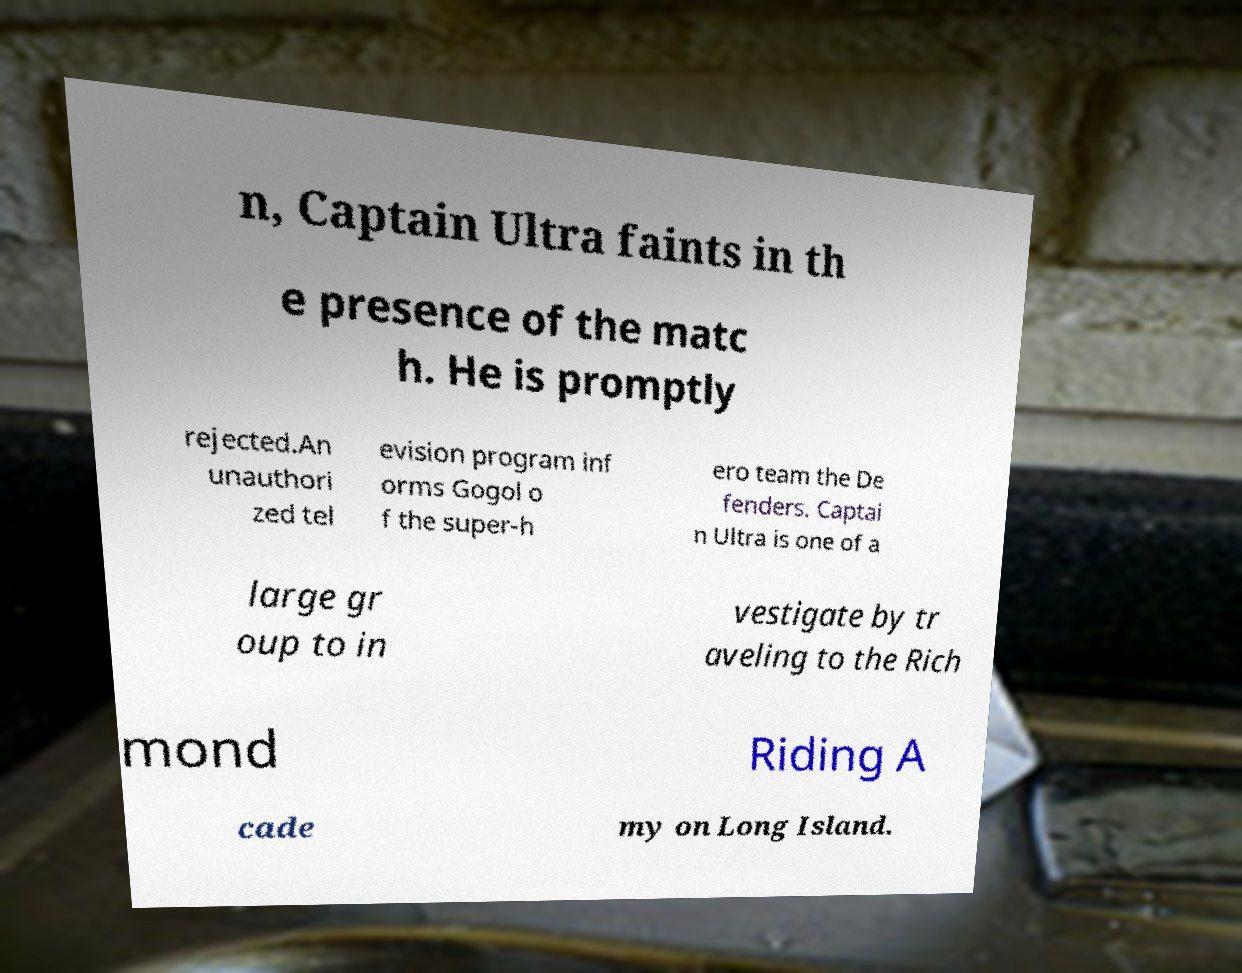I need the written content from this picture converted into text. Can you do that? n, Captain Ultra faints in th e presence of the matc h. He is promptly rejected.An unauthori zed tel evision program inf orms Gogol o f the super-h ero team the De fenders. Captai n Ultra is one of a large gr oup to in vestigate by tr aveling to the Rich mond Riding A cade my on Long Island. 